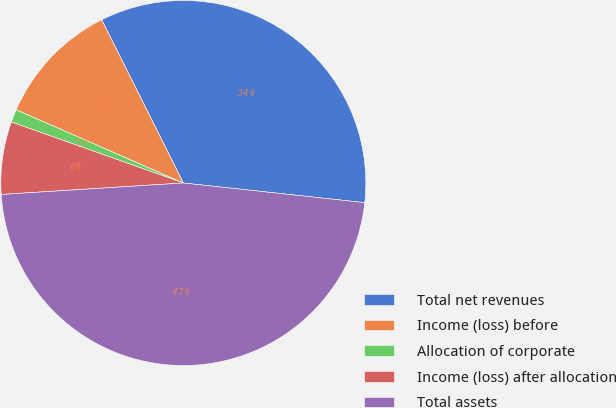<chart> <loc_0><loc_0><loc_500><loc_500><pie_chart><fcel>Total net revenues<fcel>Income (loss) before<fcel>Allocation of corporate<fcel>Income (loss) after allocation<fcel>Total assets<nl><fcel>34.1%<fcel>11.05%<fcel>1.14%<fcel>6.43%<fcel>47.28%<nl></chart> 